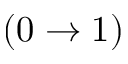Convert formula to latex. <formula><loc_0><loc_0><loc_500><loc_500>( 0 \rightarrow 1 )</formula> 